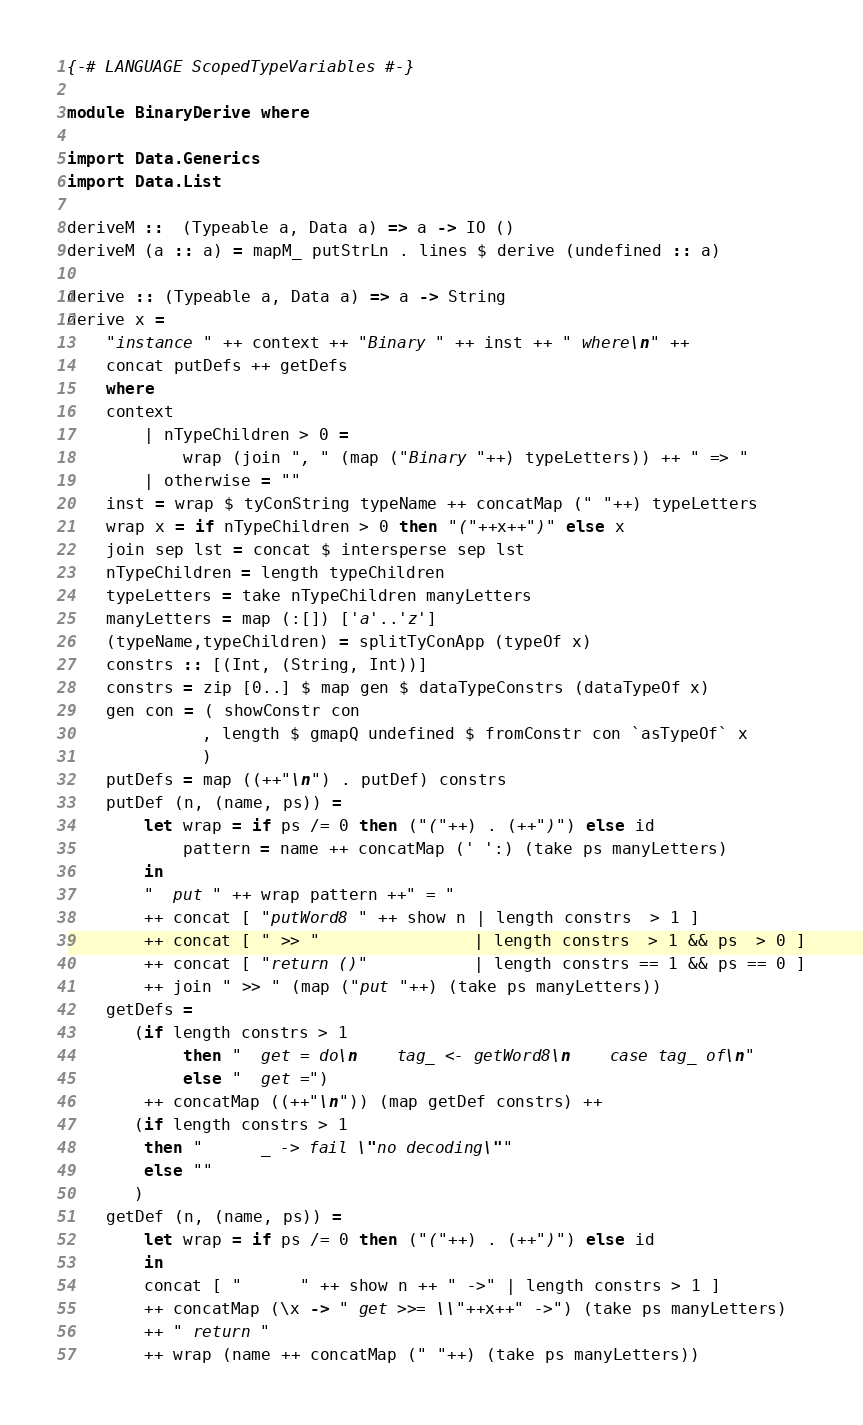<code> <loc_0><loc_0><loc_500><loc_500><_Haskell_>{-# LANGUAGE ScopedTypeVariables #-}

module BinaryDerive where

import Data.Generics
import Data.List

deriveM ::  (Typeable a, Data a) => a -> IO ()
deriveM (a :: a) = mapM_ putStrLn . lines $ derive (undefined :: a)

derive :: (Typeable a, Data a) => a -> String
derive x = 
    "instance " ++ context ++ "Binary " ++ inst ++ " where\n" ++
    concat putDefs ++ getDefs
    where
    context
        | nTypeChildren > 0 =
            wrap (join ", " (map ("Binary "++) typeLetters)) ++ " => "
        | otherwise = ""
    inst = wrap $ tyConString typeName ++ concatMap (" "++) typeLetters
    wrap x = if nTypeChildren > 0 then "("++x++")" else x 
    join sep lst = concat $ intersperse sep lst
    nTypeChildren = length typeChildren
    typeLetters = take nTypeChildren manyLetters
    manyLetters = map (:[]) ['a'..'z']
    (typeName,typeChildren) = splitTyConApp (typeOf x)
    constrs :: [(Int, (String, Int))]
    constrs = zip [0..] $ map gen $ dataTypeConstrs (dataTypeOf x)
    gen con = ( showConstr con
              , length $ gmapQ undefined $ fromConstr con `asTypeOf` x
              )
    putDefs = map ((++"\n") . putDef) constrs
    putDef (n, (name, ps)) =
        let wrap = if ps /= 0 then ("("++) . (++")") else id
            pattern = name ++ concatMap (' ':) (take ps manyLetters)
        in
        "  put " ++ wrap pattern ++" = "
        ++ concat [ "putWord8 " ++ show n | length constrs  > 1 ]
        ++ concat [ " >> "                | length constrs  > 1 && ps  > 0 ]
        ++ concat [ "return ()"           | length constrs == 1 && ps == 0 ]
        ++ join " >> " (map ("put "++) (take ps manyLetters))
    getDefs =
       (if length constrs > 1
            then "  get = do\n    tag_ <- getWord8\n    case tag_ of\n"
            else "  get =")
        ++ concatMap ((++"\n")) (map getDef constrs) ++
       (if length constrs > 1
	    then "      _ -> fail \"no decoding\""
	    else ""
       )
    getDef (n, (name, ps)) =
        let wrap = if ps /= 0 then ("("++) . (++")") else id
        in
        concat [ "      " ++ show n ++ " ->" | length constrs > 1 ]
        ++ concatMap (\x -> " get >>= \\"++x++" ->") (take ps manyLetters)
        ++ " return "
        ++ wrap (name ++ concatMap (" "++) (take ps manyLetters))
</code> 